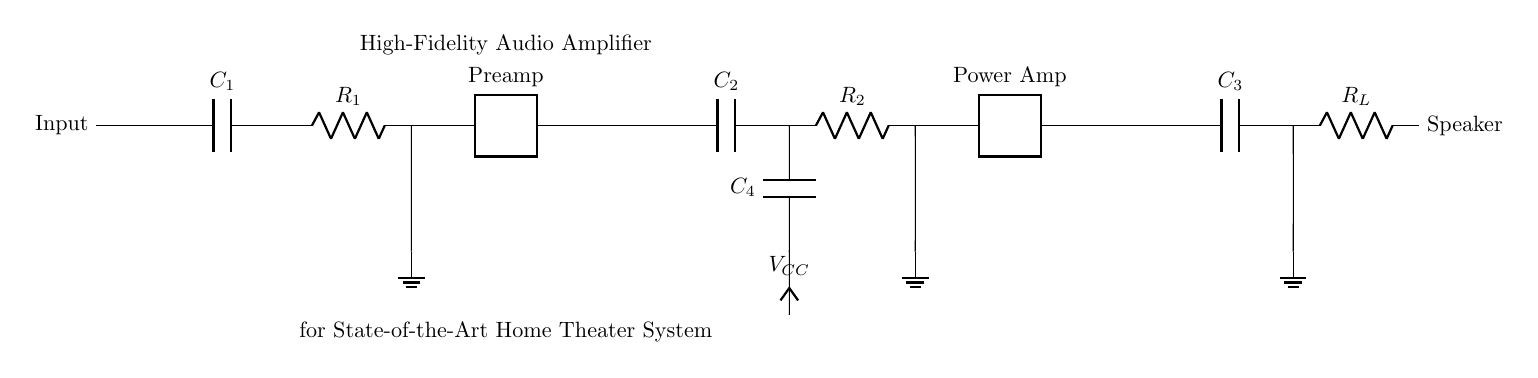What type of components are used in this amplifier circuit? The circuit includes capacitors, resistors, and two-port amplifiers for the preamp and power amp stages. These components work together to amplify the audio signal while maintaining fidelity.
Answer: Capacitors, resistors, two-port amplifiers What is the purpose of C1 in the input stage? C1 acts as a coupling capacitor, allowing AC signals to pass while blocking DC voltages. This ensures that the audio signal is correctly amplified without affecting the operating point of subsequent stages.
Answer: Coupling What does R_L represent in the output stage? R_L represents the load resistor, which in this context is the speaker. The load resistor is essential for converting the amplified signal back into sound that can be heard.
Answer: Speaker How many stages are present in this audio amplifier circuit? The circuit consists of three stages: input, gain, and output. Each stage plays a critical role in processing the audio signal.
Answer: Three What is the significance of V_CC in this circuit? V_CC is the supply voltage that powers the circuit. It is essential for the operational amplifiers to function and provides the necessary energy for amplification.
Answer: Supply voltage What function does C4 serve in the circuit? C4 is a power supply bypass capacitor that helps to stabilize the supply voltage by filtering out noise and transients, ensuring reliable operation of the amplifier.
Answer: Stabilization 